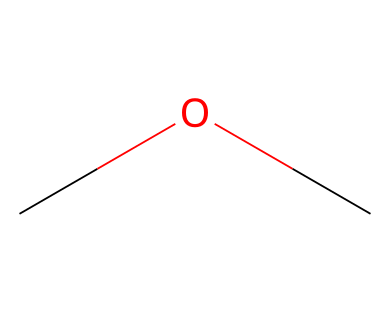How many carbon atoms are in dimethyl ether? The SMILES representation "COC" indicates the presence of two carbon (C) atoms. Each "C" represents a carbon atom in the structure.
Answer: 2 What functional group is present in dimethyl ether? The molecule contains an ether functional group, which is characterized by an oxygen atom bonded between two carbon atoms. The "C-O-C" arrangement identifies it as an ether.
Answer: ether What is the molecular formula for dimethyl ether? To determine the molecular formula, we count the atoms in the SMILES: 2 carbons (C), 6 hydrogens (H), and 1 oxygen (O). Thus, the formula is C2H6O.
Answer: C2H6O What type of chemical bond connects the oxygen to the carbon atoms in dimethyl ether? In the structure "COC", the bond between the carbon and oxygen atoms is a covalent bond. This type of bond involves the sharing of electron pairs between atoms.
Answer: covalent What does the presence of two methyl groups in dimethyl ether suggest about its volatility? The two methyl groups (–CH3) suggest that dimethyl ether has a lower molecular weight, contributing to its higher volatility compared to longer-chain ethers. Lower molecular weight generally increases volatility.
Answer: higher Is dimethyl ether polar or nonpolar? Considering the structure, while there is an electronegative oxygen atom creating a dipole moment, the symmetrical arrangement of the two methyl groups allows charge distribution to balance, making the overall molecule nonpolar.
Answer: nonpolar 